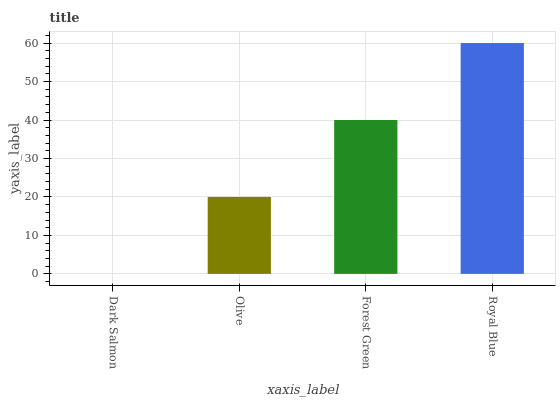Is Dark Salmon the minimum?
Answer yes or no. Yes. Is Royal Blue the maximum?
Answer yes or no. Yes. Is Olive the minimum?
Answer yes or no. No. Is Olive the maximum?
Answer yes or no. No. Is Olive greater than Dark Salmon?
Answer yes or no. Yes. Is Dark Salmon less than Olive?
Answer yes or no. Yes. Is Dark Salmon greater than Olive?
Answer yes or no. No. Is Olive less than Dark Salmon?
Answer yes or no. No. Is Forest Green the high median?
Answer yes or no. Yes. Is Olive the low median?
Answer yes or no. Yes. Is Dark Salmon the high median?
Answer yes or no. No. Is Royal Blue the low median?
Answer yes or no. No. 